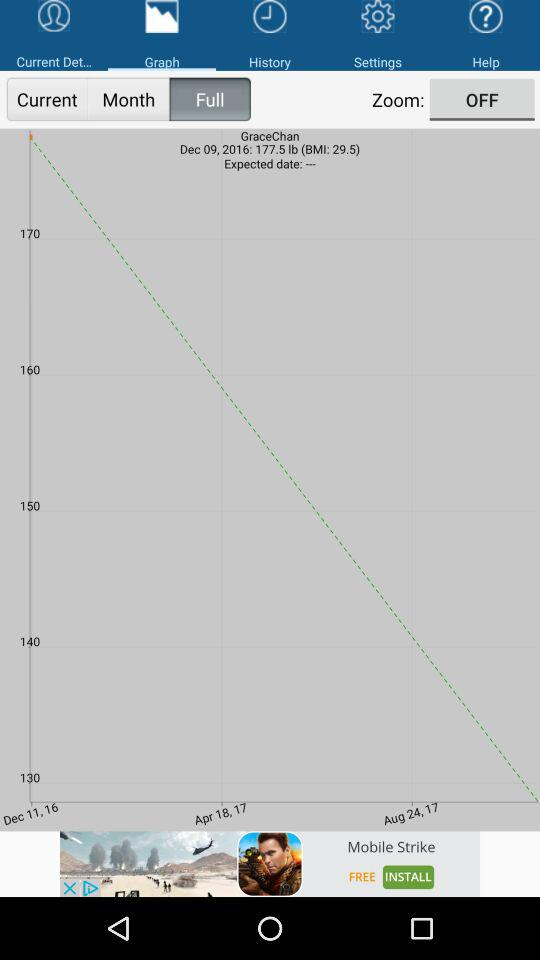What is the BMI number? The BMI number is 29.5. 